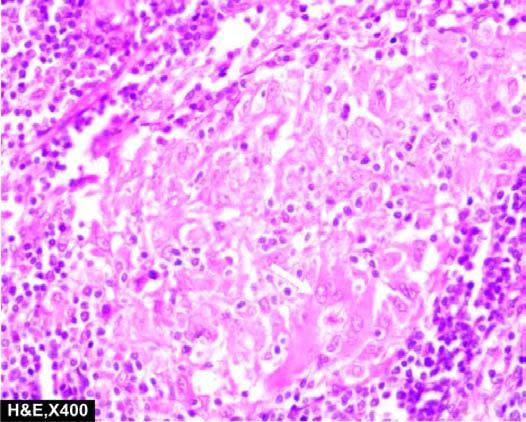what is a giant cell with inclusions seen in?
Answer the question using a single word or phrase. Photomicrograph 